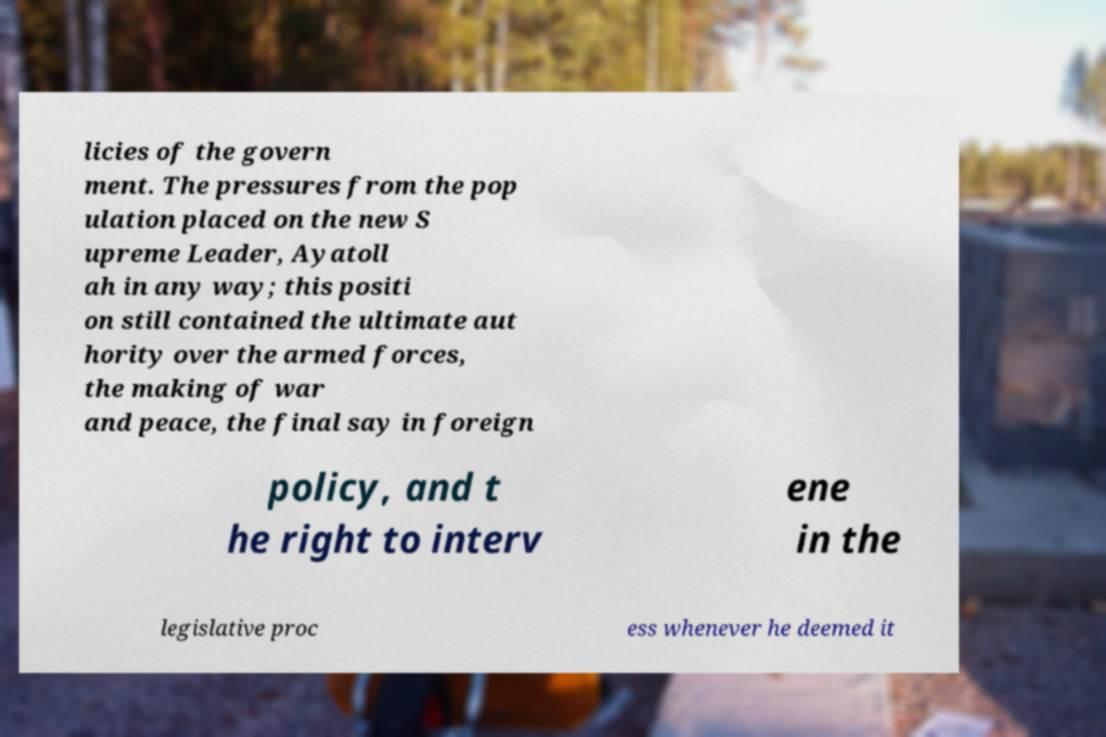I need the written content from this picture converted into text. Can you do that? licies of the govern ment. The pressures from the pop ulation placed on the new S upreme Leader, Ayatoll ah in any way; this positi on still contained the ultimate aut hority over the armed forces, the making of war and peace, the final say in foreign policy, and t he right to interv ene in the legislative proc ess whenever he deemed it 